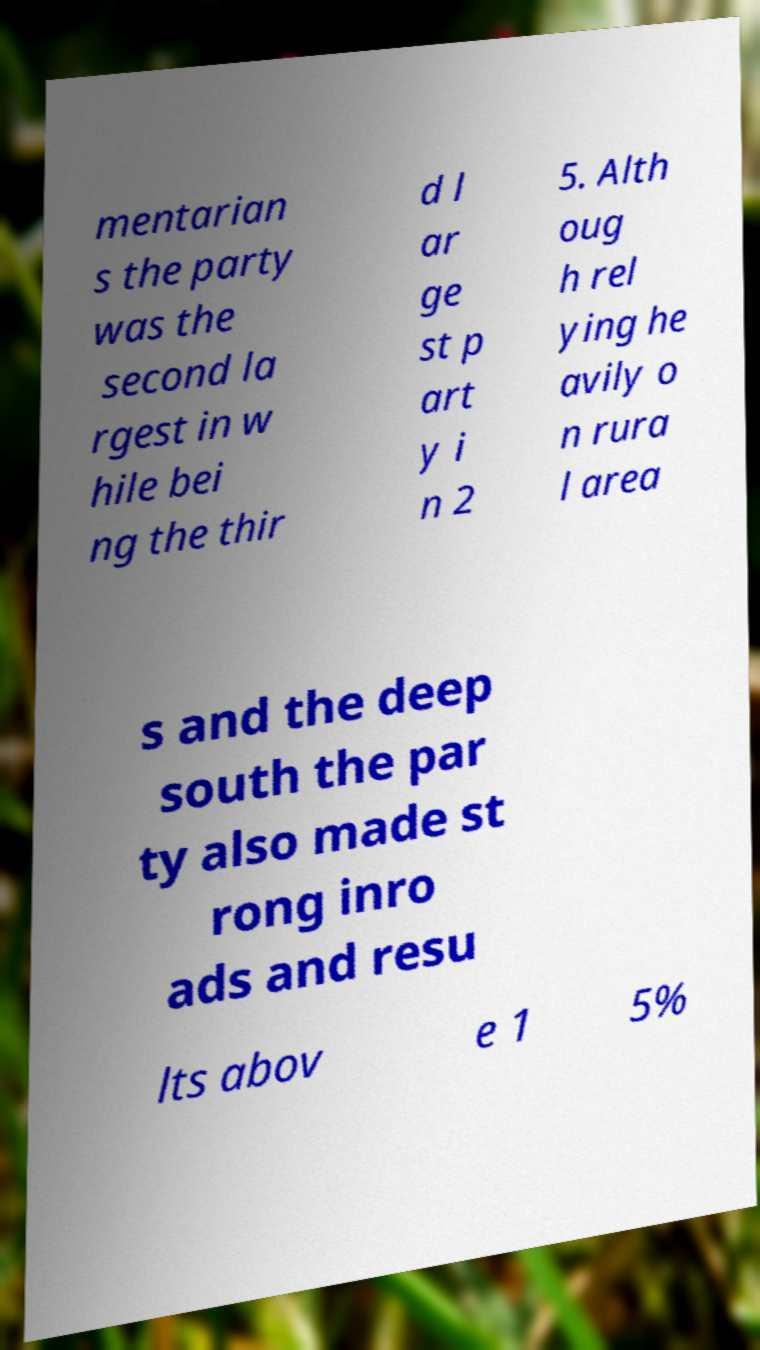For documentation purposes, I need the text within this image transcribed. Could you provide that? mentarian s the party was the second la rgest in w hile bei ng the thir d l ar ge st p art y i n 2 5. Alth oug h rel ying he avily o n rura l area s and the deep south the par ty also made st rong inro ads and resu lts abov e 1 5% 